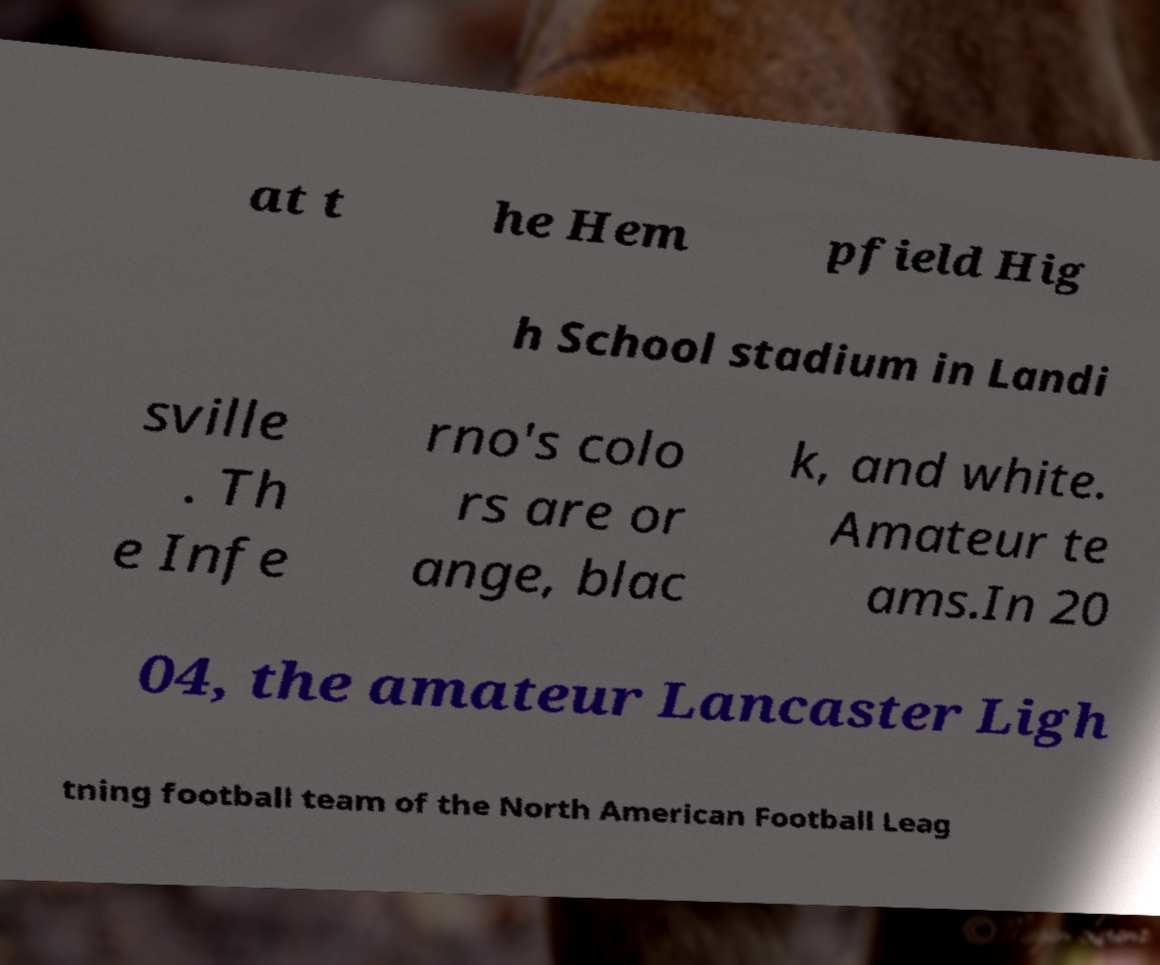For documentation purposes, I need the text within this image transcribed. Could you provide that? at t he Hem pfield Hig h School stadium in Landi sville . Th e Infe rno's colo rs are or ange, blac k, and white. Amateur te ams.In 20 04, the amateur Lancaster Ligh tning football team of the North American Football Leag 